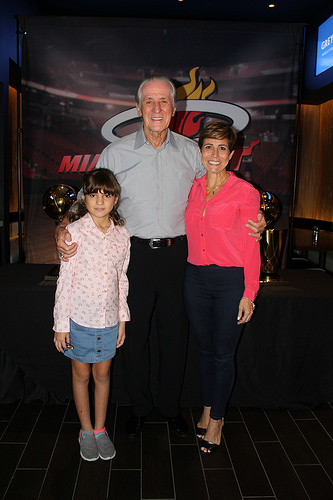<image>
Is there a girl to the left of the girl? Yes. From this viewpoint, the girl is positioned to the left side relative to the girl. 